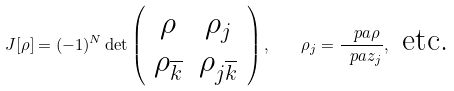Convert formula to latex. <formula><loc_0><loc_0><loc_500><loc_500>J [ \rho ] = ( - 1 ) ^ { N } \det \left ( \begin{array} { c c } \rho & \rho _ { j } \\ \rho _ { \overline { k } } & \rho _ { j \overline { k } } \end{array} \right ) , \quad \rho _ { j } = \frac { \ p a \rho } { \ p a { z _ { j } } } , \text { etc.}</formula> 